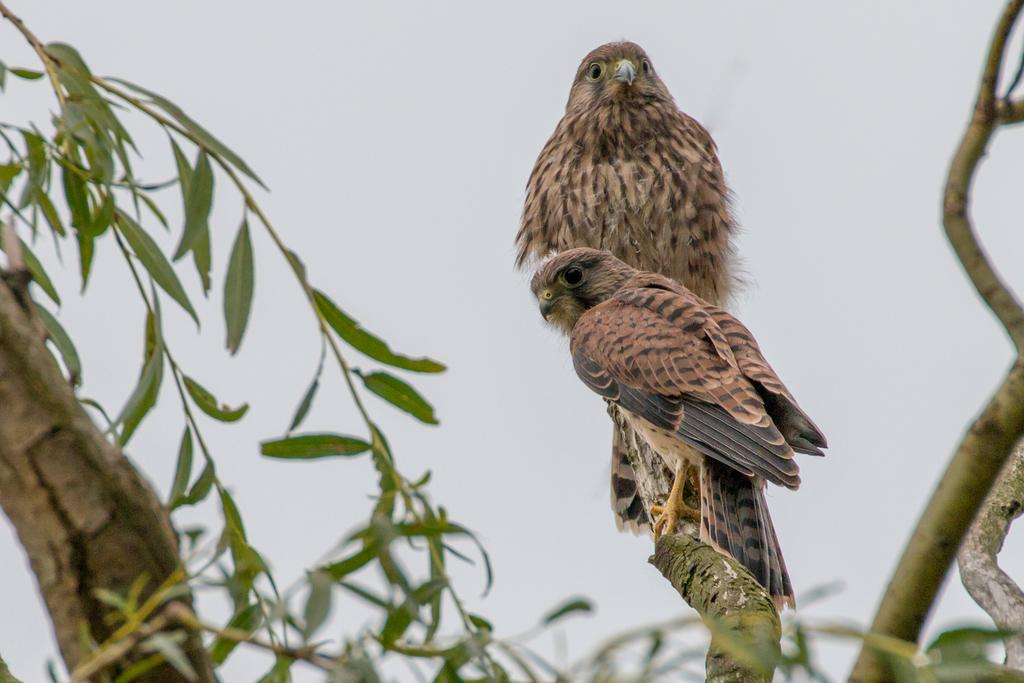What animals are present in the image? There are two hawks in the image. Where are the hawks located? The hawks are standing on a tree stem. What type of vegetation can be seen on the left side of the image? There are green leaves on the left side of the image. What can be seen on the right side of the image? There are tree stems on the right side of the image. Can you see any scissors being used by the hawks in the image? There are no scissors present in the image, and the hawks are not using any tools. Are there any fairies visible in the image? There are no fairies present in the image; it features two hawks standing on a tree stem. 